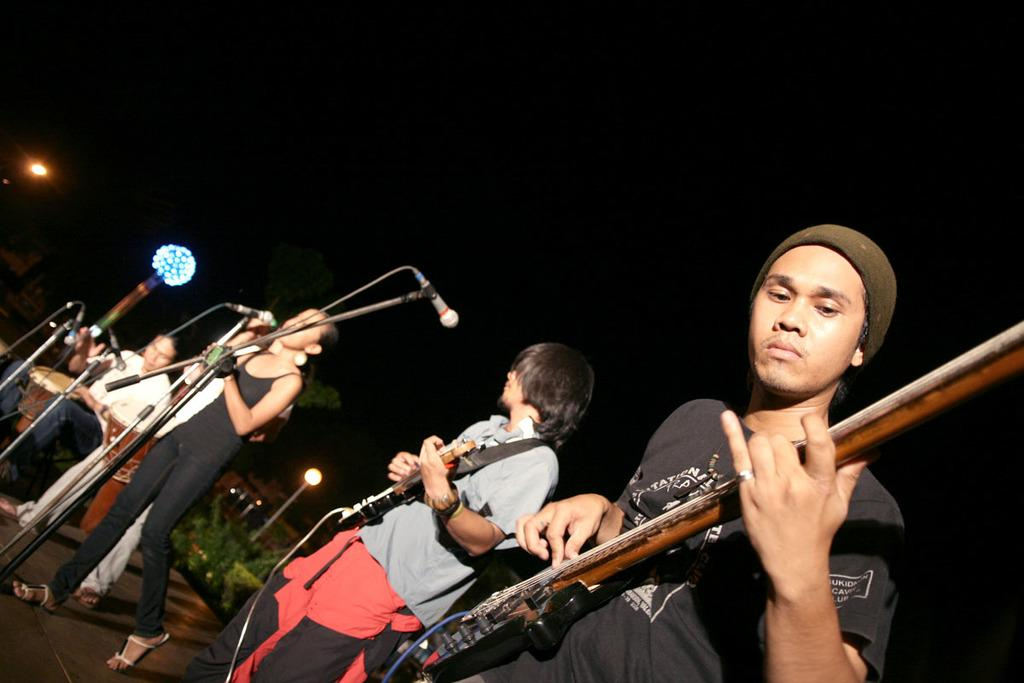What are the people in the image doing? Some of the people are playing musical instruments. What object is present for amplifying sound? There is a microphone (mic) in the image. What structure can be seen in the image? There is a stand in the image. What architectural features are visible in the image? There are light poles in the image. What type of vegetation is present in the image? There are trees in the image. What is the color of the background in the image? The background of the image is dark. What grade is the banana being held by the pet in the image? There is no banana or pet present in the image. How does the pet interact with the musical instruments in the image? There is no pet present in the image, so it cannot interact with the musical instruments. 